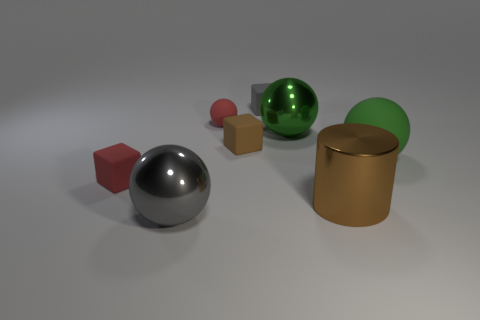There is a large green object that is made of the same material as the large brown cylinder; what is its shape?
Offer a terse response. Sphere. How many small things are green rubber things or rubber cubes?
Provide a short and direct response. 3. Are there any large green matte balls that are behind the thing that is on the right side of the cylinder?
Offer a very short reply. No. Is there a green matte object?
Your answer should be compact. Yes. What color is the thing on the left side of the gray object in front of the small gray matte object?
Offer a terse response. Red. What material is the small red thing that is the same shape as the small brown rubber object?
Offer a terse response. Rubber. What number of rubber spheres have the same size as the brown shiny cylinder?
Offer a very short reply. 1. There is a green sphere that is made of the same material as the red cube; what is its size?
Your response must be concise. Large. What number of green shiny things are the same shape as the large gray object?
Your answer should be very brief. 1. What number of large balls are there?
Offer a terse response. 3. 